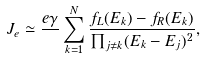Convert formula to latex. <formula><loc_0><loc_0><loc_500><loc_500>J _ { e } \simeq \frac { e \gamma } { } \sum _ { k = 1 } ^ { N } \frac { f _ { L } ( E _ { k } ) - f _ { R } ( E _ { k } ) } { \prod _ { j \neq k } ( E _ { k } - E _ { j } ) ^ { 2 } } ,</formula> 